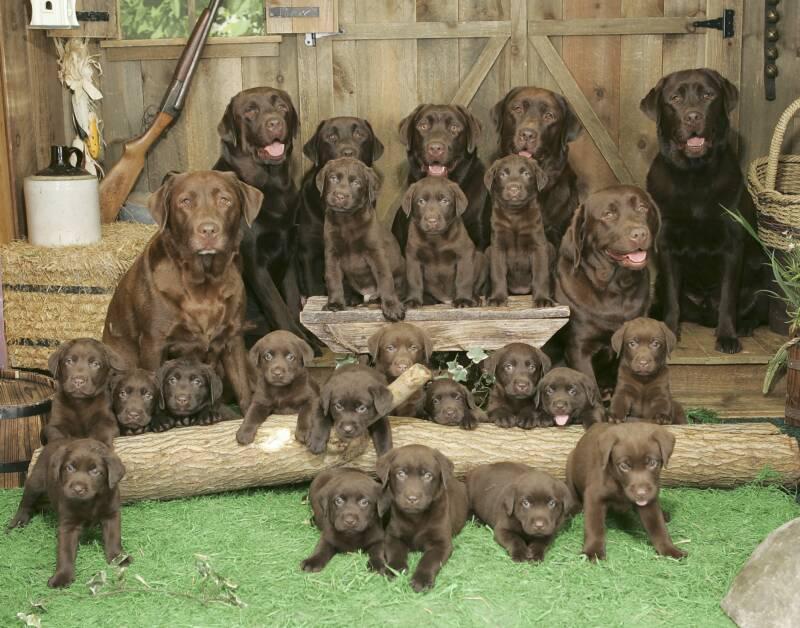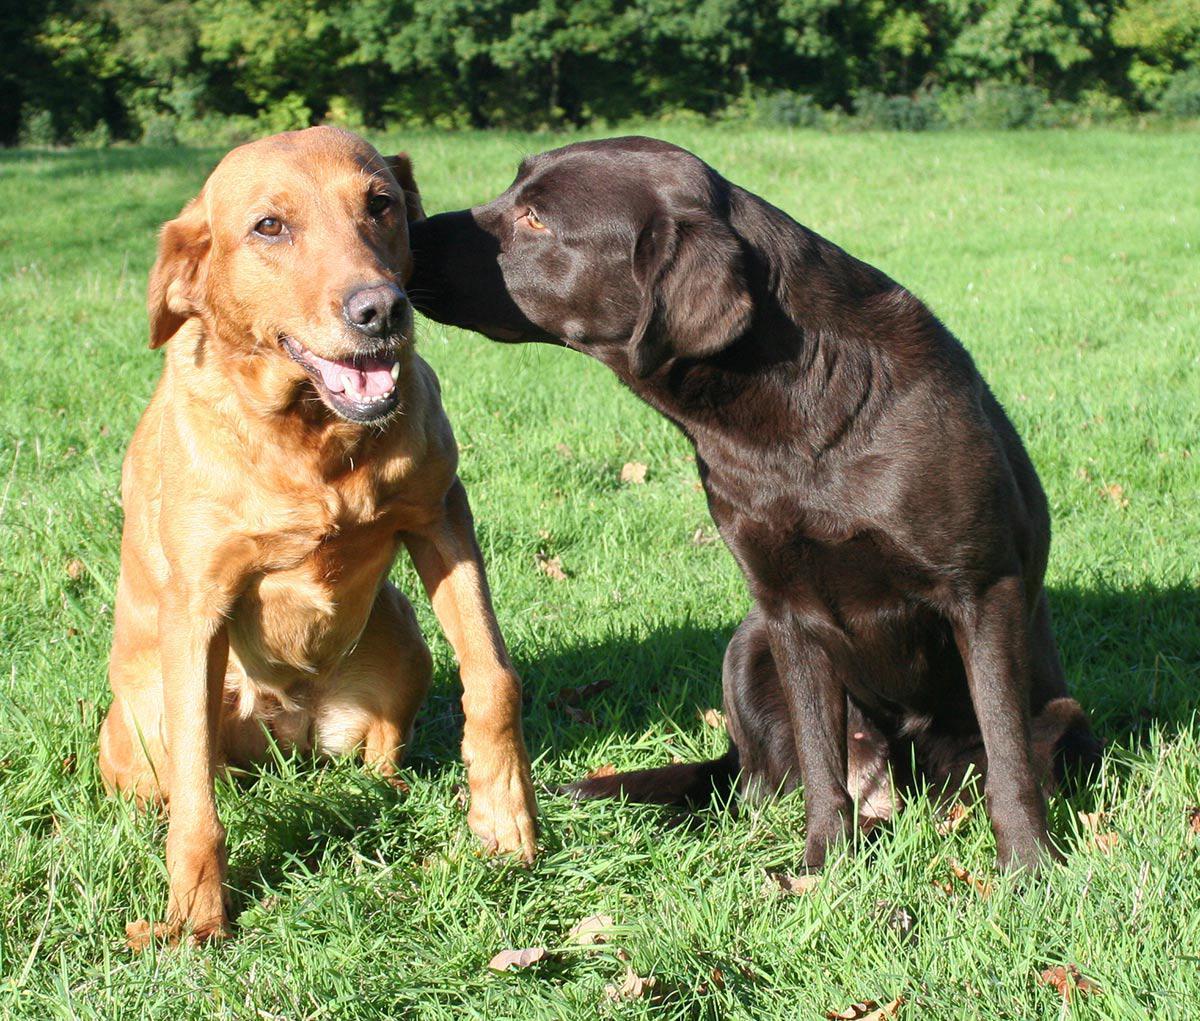The first image is the image on the left, the second image is the image on the right. Analyze the images presented: Is the assertion "No grassy ground is visible in one of the dog images." valid? Answer yes or no. No. 